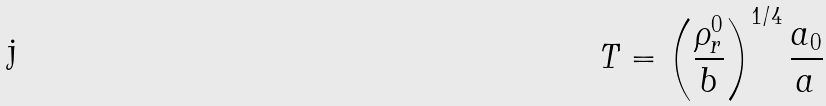Convert formula to latex. <formula><loc_0><loc_0><loc_500><loc_500>T = \left ( \frac { \rho _ { r } ^ { 0 } } { b } \right ) ^ { 1 / 4 } \frac { a _ { 0 } } { a }</formula> 